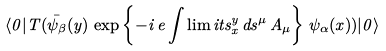Convert formula to latex. <formula><loc_0><loc_0><loc_500><loc_500>\langle 0 | T ( \bar { \psi } _ { \beta } ( y ) \, \exp \left \{ - i \, e \int \lim i t s _ { x } ^ { y } \, d s ^ { \mu } \, A _ { \mu } \right \} \, \psi _ { \alpha } ( x ) ) | 0 \rangle</formula> 